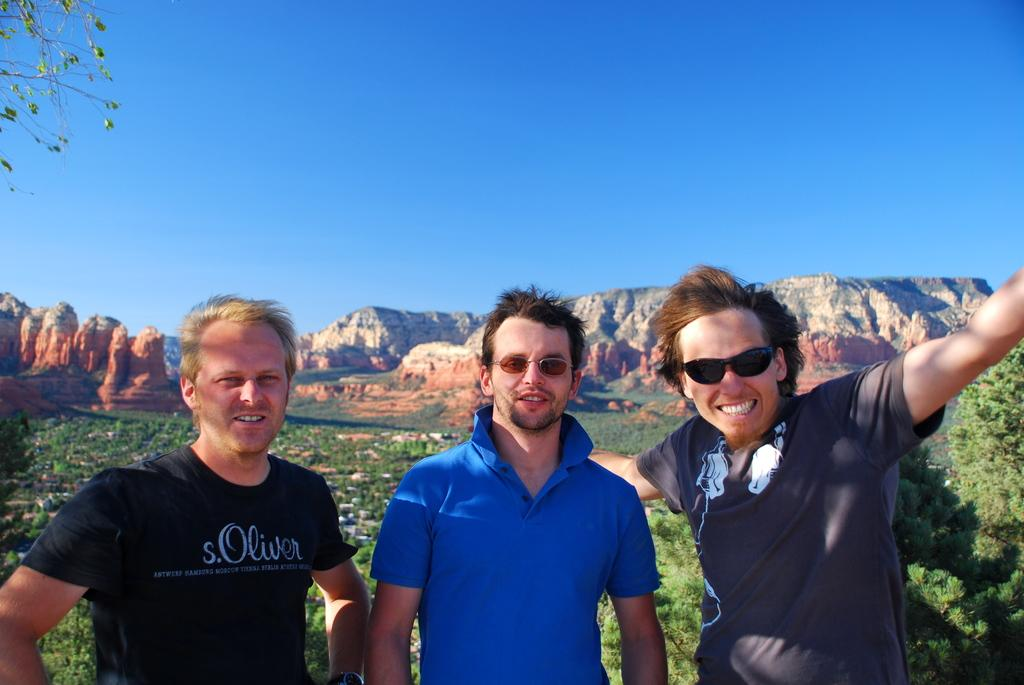What is happening in the center of the image? There are people standing in the center of the image. What can be seen in the distance behind the people? There are mountains in the background of the image. What is visible at the top of the image? The sky is visible at the top of the image. What type of vegetation is present in the image? There are trees in the image. Where is the notebook located in the image? There is no notebook present in the image. What type of flame can be seen coming from the trees in the image? There are no flames present in the image; it features people, mountains, sky, and trees. 